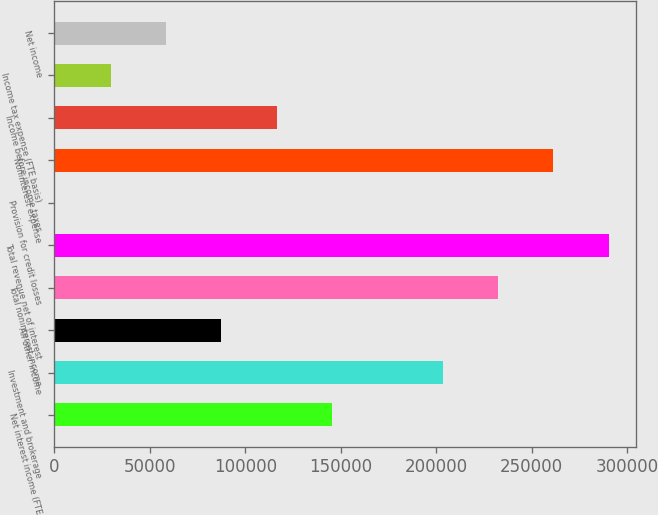Convert chart. <chart><loc_0><loc_0><loc_500><loc_500><bar_chart><fcel>Net interest income (FTE<fcel>Investment and brokerage<fcel>All other income<fcel>Total noninterest income<fcel>Total revenue net of interest<fcel>Provision for credit losses<fcel>Noninterest expense<fcel>Income before income taxes<fcel>Income tax expense (FTE basis)<fcel>Net income<nl><fcel>145378<fcel>203369<fcel>87385.7<fcel>232365<fcel>290357<fcel>398<fcel>261361<fcel>116382<fcel>29393.9<fcel>58389.8<nl></chart> 